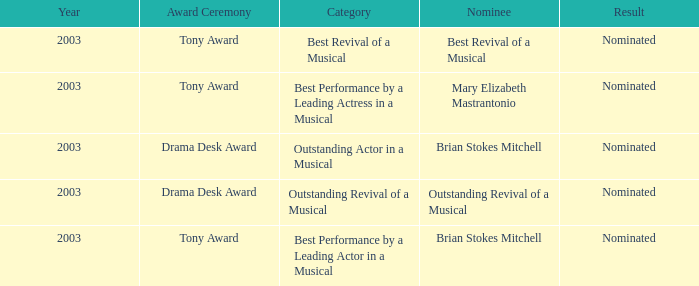What year was Mary Elizabeth Mastrantonio nominated? 2003.0. 